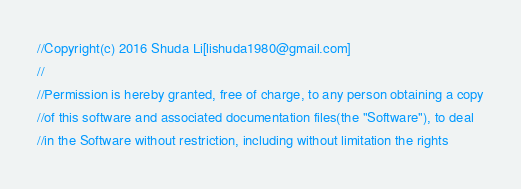Convert code to text. <code><loc_0><loc_0><loc_500><loc_500><_C++_>//Copyright(c) 2016 Shuda Li[lishuda1980@gmail.com]
//
//Permission is hereby granted, free of charge, to any person obtaining a copy
//of this software and associated documentation files(the "Software"), to deal
//in the Software without restriction, including without limitation the rights</code> 